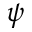<formula> <loc_0><loc_0><loc_500><loc_500>\psi</formula> 